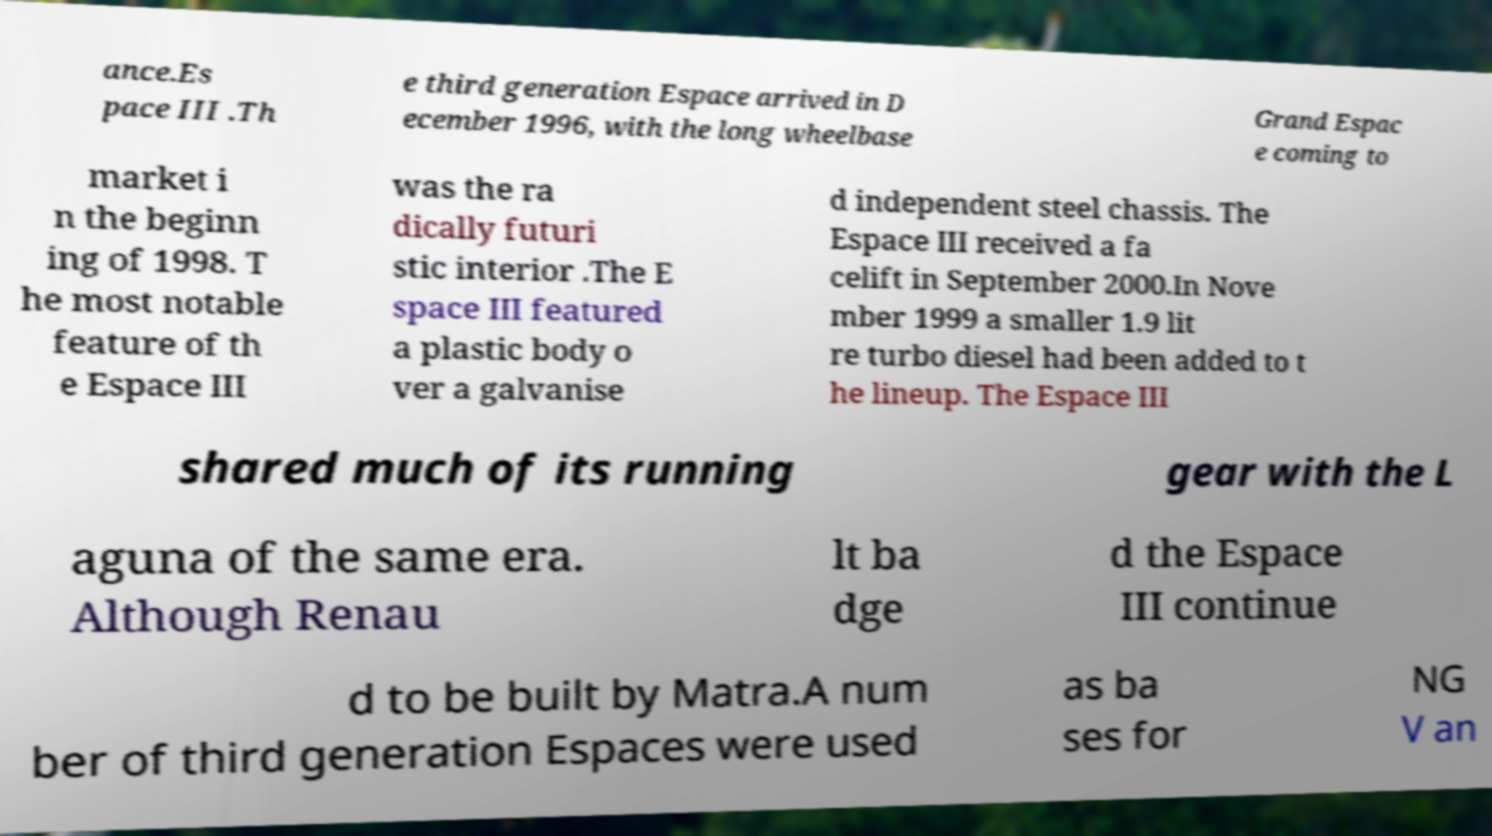Please identify and transcribe the text found in this image. ance.Es pace III .Th e third generation Espace arrived in D ecember 1996, with the long wheelbase Grand Espac e coming to market i n the beginn ing of 1998. T he most notable feature of th e Espace III was the ra dically futuri stic interior .The E space III featured a plastic body o ver a galvanise d independent steel chassis. The Espace III received a fa celift in September 2000.In Nove mber 1999 a smaller 1.9 lit re turbo diesel had been added to t he lineup. The Espace III shared much of its running gear with the L aguna of the same era. Although Renau lt ba dge d the Espace III continue d to be built by Matra.A num ber of third generation Espaces were used as ba ses for NG V an 